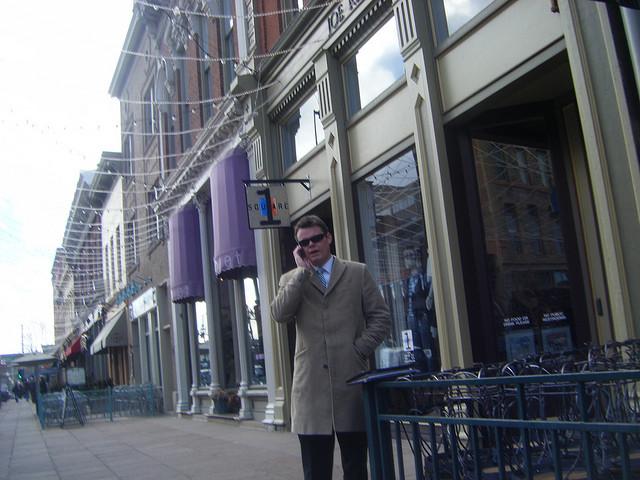Is this in the USA?
Quick response, please. Yes. Is square 1 a restaurant?
Short answer required. Yes. Is the man talking on the phone?
Short answer required. Yes. What type of glasses is the man wearing?
Give a very brief answer. Sunglasses. What kind of activity is the man performing?
Answer briefly. Talking on phone. Is the guy wearing a hat?
Write a very short answer. No. 